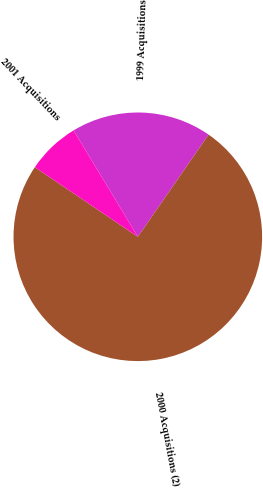<chart> <loc_0><loc_0><loc_500><loc_500><pie_chart><fcel>1999 Acquisitions<fcel>2000 Acquisitions (2)<fcel>2001 Acquisitions<nl><fcel>18.28%<fcel>74.81%<fcel>6.9%<nl></chart> 